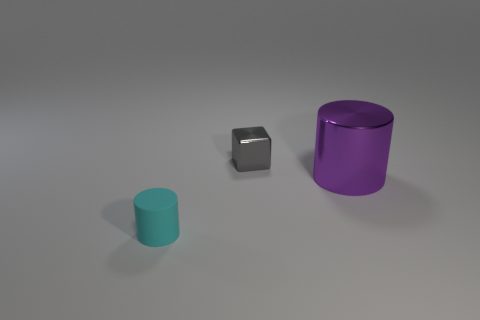Add 2 large green metal cubes. How many objects exist? 5 Subtract all cubes. How many objects are left? 2 Add 3 gray blocks. How many gray blocks are left? 4 Add 2 large purple cylinders. How many large purple cylinders exist? 3 Subtract 0 red cylinders. How many objects are left? 3 Subtract all small purple shiny spheres. Subtract all large purple metal things. How many objects are left? 2 